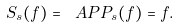<formula> <loc_0><loc_0><loc_500><loc_500>S _ { s } ( f ) = \ A P P _ { s } ( f ) = f .</formula> 